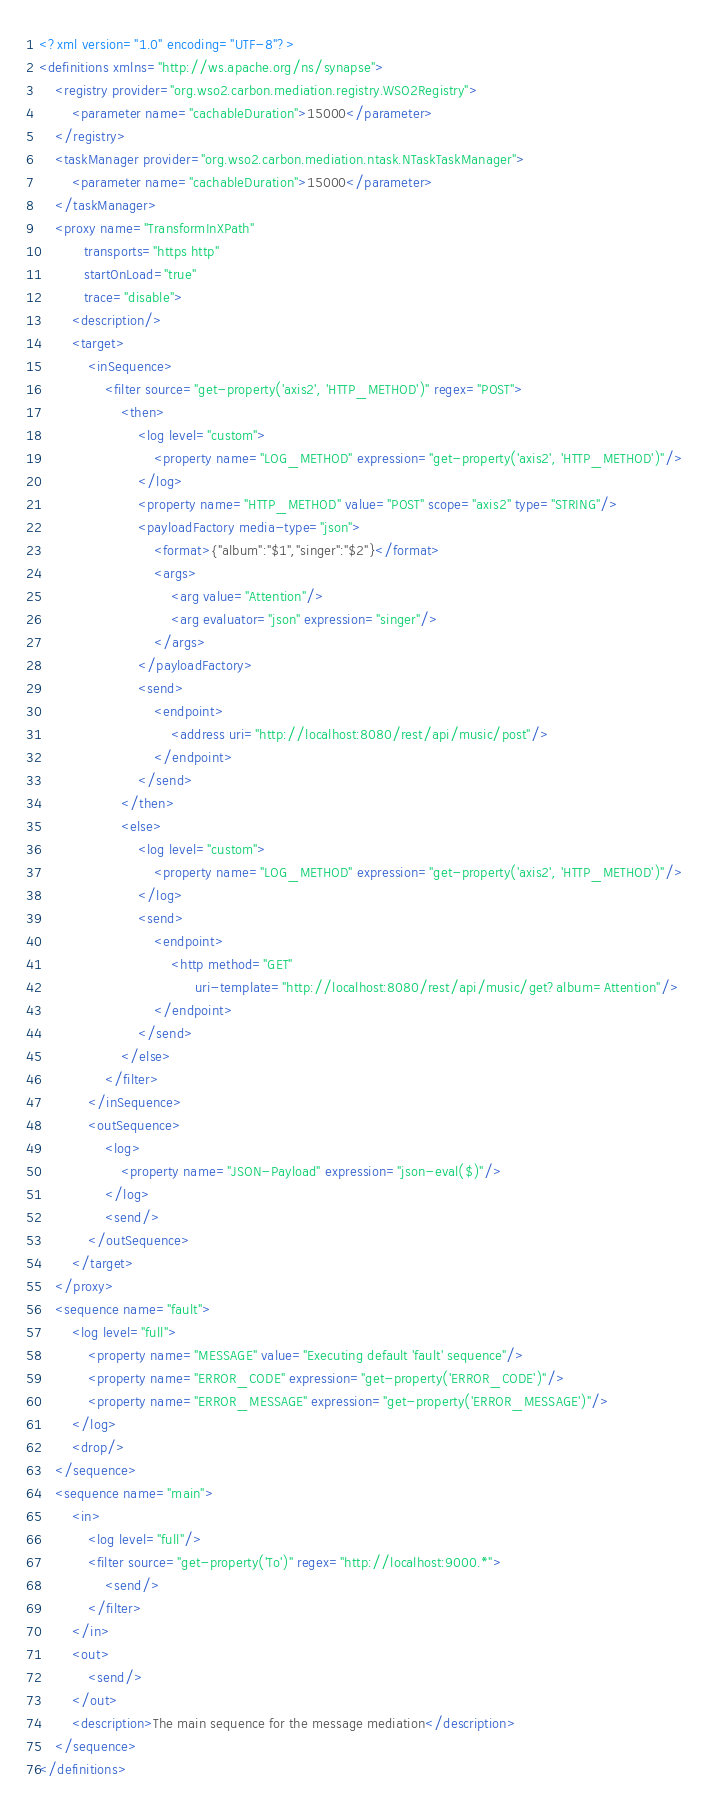Convert code to text. <code><loc_0><loc_0><loc_500><loc_500><_XML_><?xml version="1.0" encoding="UTF-8"?>
<definitions xmlns="http://ws.apache.org/ns/synapse">
    <registry provider="org.wso2.carbon.mediation.registry.WSO2Registry">
        <parameter name="cachableDuration">15000</parameter>
    </registry>
    <taskManager provider="org.wso2.carbon.mediation.ntask.NTaskTaskManager">
        <parameter name="cachableDuration">15000</parameter>
    </taskManager>
    <proxy name="TransformInXPath"
           transports="https http"
           startOnLoad="true"
           trace="disable">
        <description/>
        <target>
            <inSequence>
                <filter source="get-property('axis2', 'HTTP_METHOD')" regex="POST">
                    <then>
                        <log level="custom">
                            <property name="LOG_METHOD" expression="get-property('axis2', 'HTTP_METHOD')"/>
                        </log>
                        <property name="HTTP_METHOD" value="POST" scope="axis2" type="STRING"/>
                        <payloadFactory media-type="json">
                            <format>{"album":"$1","singer":"$2"}</format>
                            <args>
                                <arg value="Attention"/>
                                <arg evaluator="json" expression="singer"/>
                            </args>
                        </payloadFactory>
                        <send>
                            <endpoint>
                                <address uri="http://localhost:8080/rest/api/music/post"/>
                            </endpoint>
                        </send>
                    </then>
                    <else>
                        <log level="custom">
                            <property name="LOG_METHOD" expression="get-property('axis2', 'HTTP_METHOD')"/>
                        </log>
                        <send>
                            <endpoint>
                                <http method="GET"
                                      uri-template="http://localhost:8080/rest/api/music/get?album=Attention"/>
                            </endpoint>
                        </send>
                    </else>
                </filter>
            </inSequence>
            <outSequence>
                <log>
                    <property name="JSON-Payload" expression="json-eval($)"/>
                </log>
                <send/>
            </outSequence>
        </target>
    </proxy>
    <sequence name="fault">
        <log level="full">
            <property name="MESSAGE" value="Executing default 'fault' sequence"/>
            <property name="ERROR_CODE" expression="get-property('ERROR_CODE')"/>
            <property name="ERROR_MESSAGE" expression="get-property('ERROR_MESSAGE')"/>
        </log>
        <drop/>
    </sequence>
    <sequence name="main">
        <in>
            <log level="full"/>
            <filter source="get-property('To')" regex="http://localhost:9000.*">
                <send/>
            </filter>
        </in>
        <out>
            <send/>
        </out>
        <description>The main sequence for the message mediation</description>
    </sequence>
</definitions></code> 